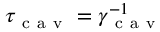Convert formula to latex. <formula><loc_0><loc_0><loc_500><loc_500>\tau _ { c a v } = \gamma _ { c a v } ^ { - 1 }</formula> 